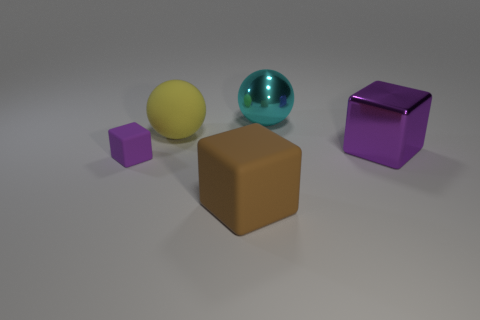Add 4 brown rubber blocks. How many objects exist? 9 Subtract all balls. How many objects are left? 3 Subtract 0 green cylinders. How many objects are left? 5 Subtract all large purple things. Subtract all metal balls. How many objects are left? 3 Add 2 purple rubber cubes. How many purple rubber cubes are left? 3 Add 1 big green matte cubes. How many big green matte cubes exist? 1 